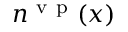<formula> <loc_0><loc_0><loc_500><loc_500>n ^ { { v p } } ( x )</formula> 